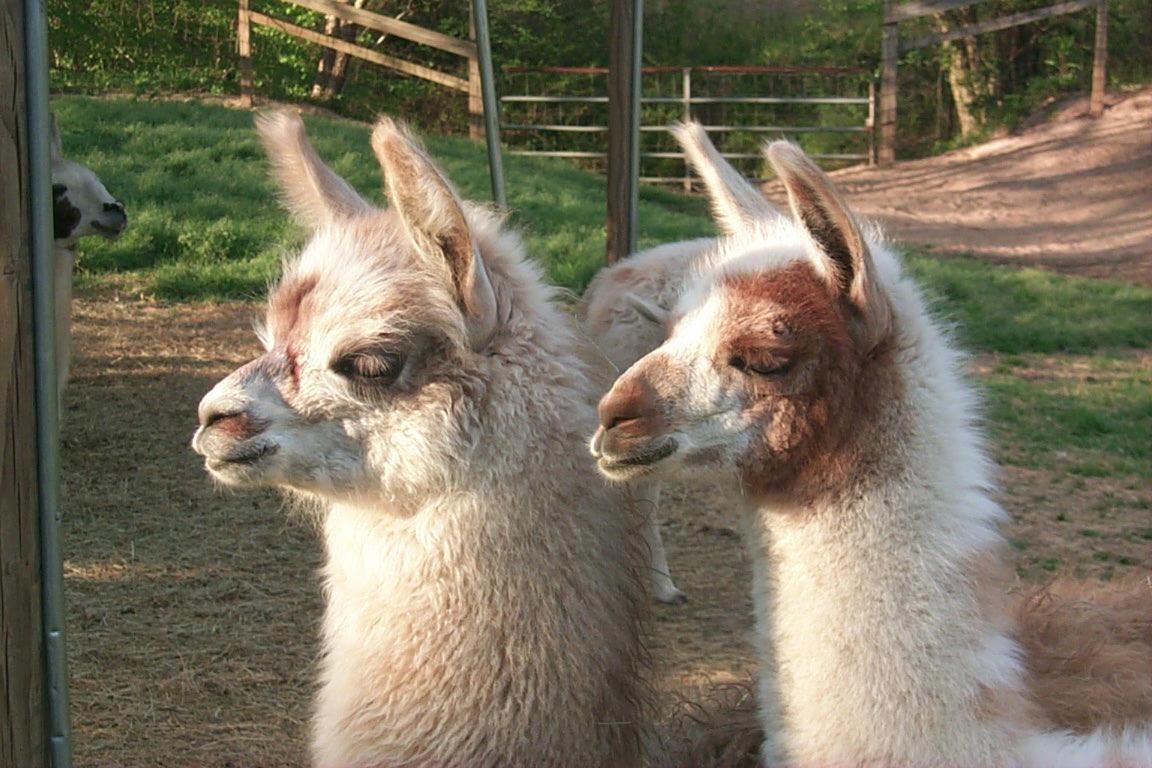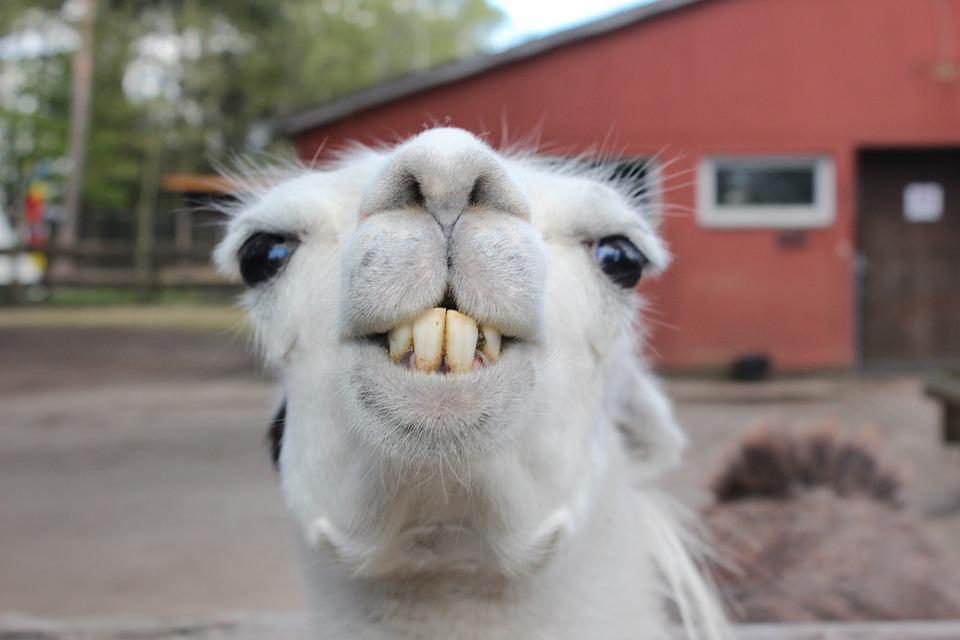The first image is the image on the left, the second image is the image on the right. Given the left and right images, does the statement "There are two llamas in one of the images." hold true? Answer yes or no. Yes. The first image is the image on the left, the second image is the image on the right. Considering the images on both sides, is "The left image contains at least three llamas standing in a row and gazing in the same direction." valid? Answer yes or no. No. 